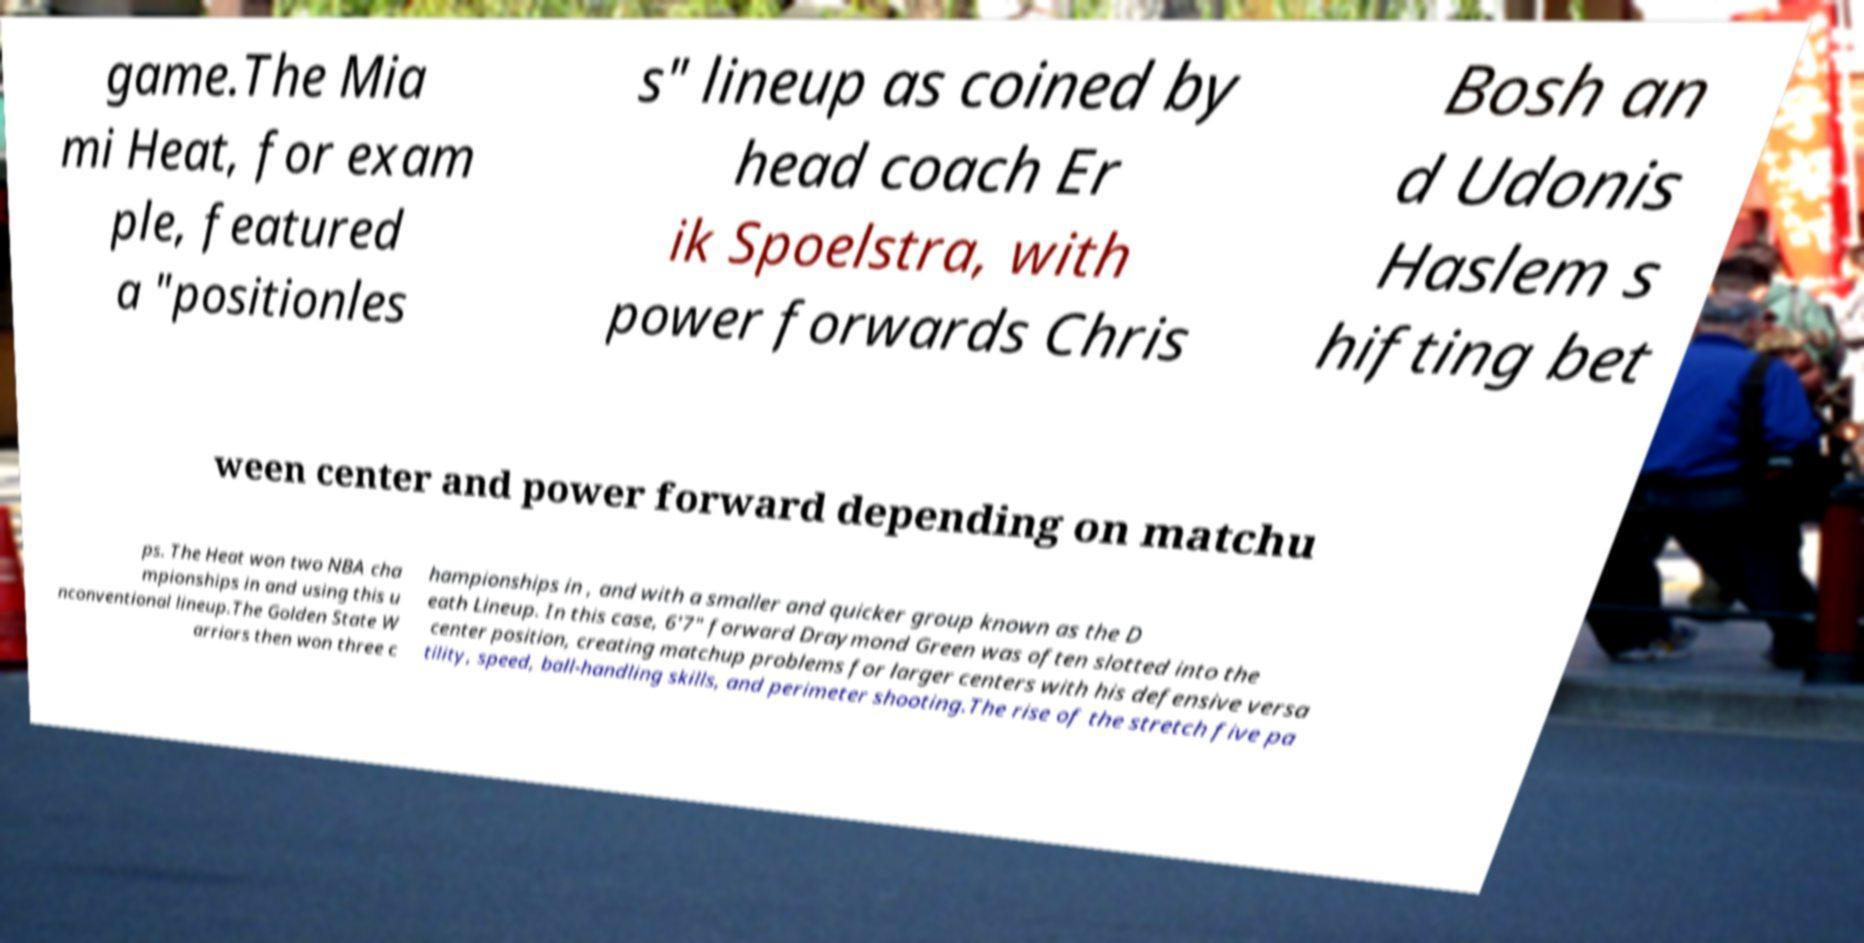Could you assist in decoding the text presented in this image and type it out clearly? game.The Mia mi Heat, for exam ple, featured a "positionles s" lineup as coined by head coach Er ik Spoelstra, with power forwards Chris Bosh an d Udonis Haslem s hifting bet ween center and power forward depending on matchu ps. The Heat won two NBA cha mpionships in and using this u nconventional lineup.The Golden State W arriors then won three c hampionships in , and with a smaller and quicker group known as the D eath Lineup. In this case, 6'7" forward Draymond Green was often slotted into the center position, creating matchup problems for larger centers with his defensive versa tility, speed, ball-handling skills, and perimeter shooting.The rise of the stretch five pa 